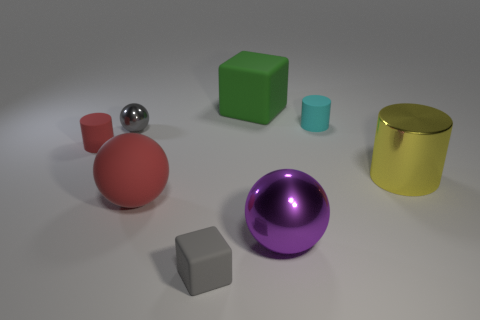Do the tiny matte cube and the small ball have the same color?
Make the answer very short. Yes. There is a tiny rubber thing to the right of the large purple object; what number of yellow metal cylinders are behind it?
Make the answer very short. 0. What size is the thing that is right of the big green matte object and in front of the big red ball?
Offer a terse response. Large. What material is the small cylinder left of the tiny cube?
Ensure brevity in your answer.  Rubber. Is there a tiny gray metal thing of the same shape as the green object?
Your answer should be very brief. No. What number of other things have the same shape as the tiny gray rubber object?
Make the answer very short. 1. There is a block behind the gray matte object; is its size the same as the metal sphere that is right of the green matte object?
Your response must be concise. Yes. What is the shape of the metal object right of the big sphere that is to the right of the gray matte block?
Your answer should be compact. Cylinder. Are there the same number of big yellow metallic objects behind the tiny gray shiny ball and large red matte objects?
Your answer should be compact. No. What material is the small red object that is on the left side of the rubber cube in front of the small cylinder that is to the right of the purple metallic sphere?
Provide a short and direct response. Rubber. 